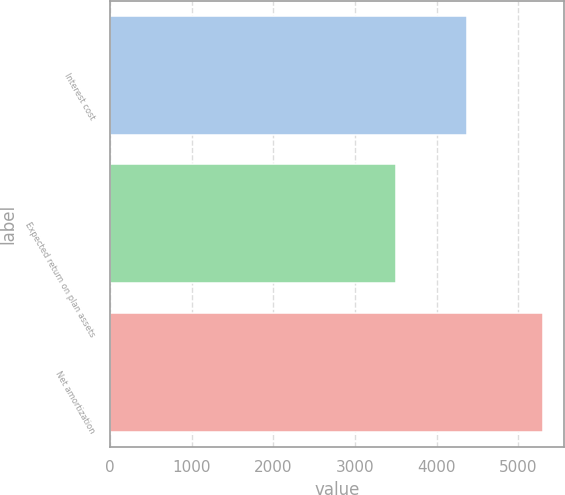<chart> <loc_0><loc_0><loc_500><loc_500><bar_chart><fcel>Interest cost<fcel>Expected return on plan assets<fcel>Net amortization<nl><fcel>4375<fcel>3505<fcel>5299<nl></chart> 